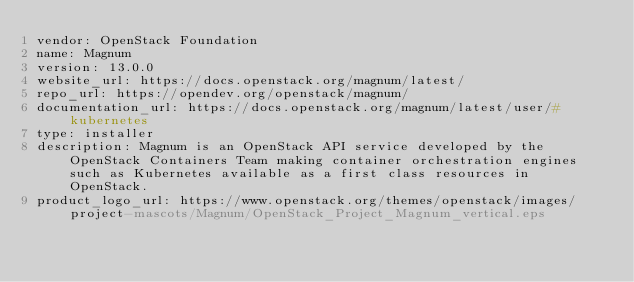<code> <loc_0><loc_0><loc_500><loc_500><_YAML_>vendor: OpenStack Foundation
name: Magnum
version: 13.0.0
website_url: https://docs.openstack.org/magnum/latest/
repo_url: https://opendev.org/openstack/magnum/
documentation_url: https://docs.openstack.org/magnum/latest/user/#kubernetes
type: installer
description: Magnum is an OpenStack API service developed by the OpenStack Containers Team making container orchestration engines such as Kubernetes available as a first class resources in OpenStack.
product_logo_url: https://www.openstack.org/themes/openstack/images/project-mascots/Magnum/OpenStack_Project_Magnum_vertical.eps
</code> 